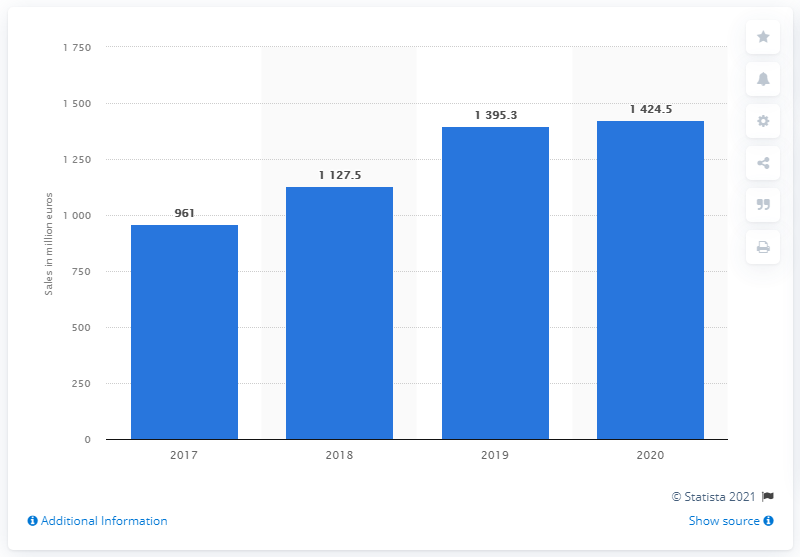Indicate a few pertinent items in this graphic. In 2020, Puma's retail and direct-to-consumer sales were 1,424.5. 